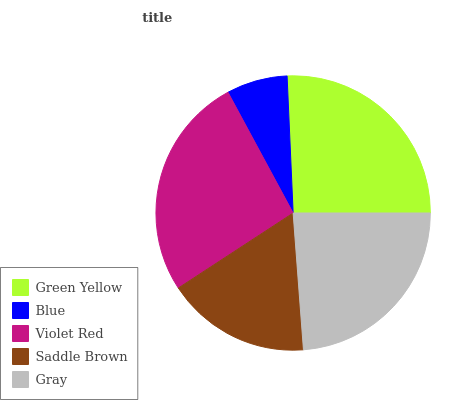Is Blue the minimum?
Answer yes or no. Yes. Is Violet Red the maximum?
Answer yes or no. Yes. Is Violet Red the minimum?
Answer yes or no. No. Is Blue the maximum?
Answer yes or no. No. Is Violet Red greater than Blue?
Answer yes or no. Yes. Is Blue less than Violet Red?
Answer yes or no. Yes. Is Blue greater than Violet Red?
Answer yes or no. No. Is Violet Red less than Blue?
Answer yes or no. No. Is Gray the high median?
Answer yes or no. Yes. Is Gray the low median?
Answer yes or no. Yes. Is Saddle Brown the high median?
Answer yes or no. No. Is Violet Red the low median?
Answer yes or no. No. 